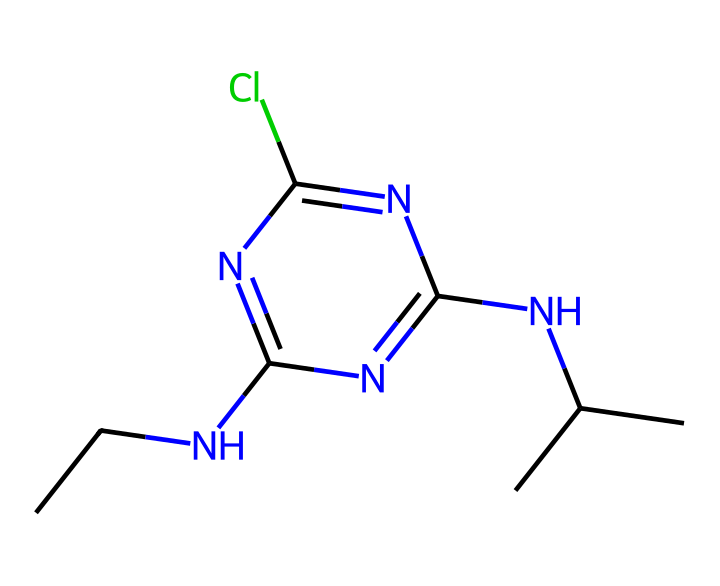What is the molecular formula for atrazine? To determine the molecular formula from the SMILES representation, count the number of each atom present. The SMILES shows 10 carbon (C) atoms, 14 hydrogen (H) atoms, 3 nitrogen (N) atoms, and 1 chlorine (Cl) atom. Therefore, the molecular formula is C8H14ClN5.
Answer: C8H14ClN5 How many nitrogen atoms are present in the atrazine molecule? By examining the SMILES structure, we can identify that there are a total of 5 nitrogen (N) atoms in the representation. Each nitrogen is counted as it appears in the structure.
Answer: 5 Which functional group is likely responsible for atrazine's herbicidal activity? From the structure, the presence of the nitrogen atoms indicates an amine functional group. These groups are often associated with biological activity, including herbicides. Thus, the amine group is likely responsible for its activity.
Answer: amine Is atrazine a single or multi-ring structure? The SMILES shows a cyclic structure (indicated by the 'c' in 'c1nc' which denotes aromatic rings), confirming that atrazine has a multi-ring configuration due to the fused nitrogen-containing rings.
Answer: multi-ring What is the significance of chlorine in atrazine's structure? Chlorine (Cl) in atrazine serves to enhance its herbicidal properties by increasing its lipophilicity, which helps it penetrate plant tissues effectively. Hence, the chlorine plays a pivotal role in its herbicidal effectiveness.
Answer: enhances herbicidal properties Does atrazine contain carbon branching in its structure? Analyzing the SMILES depiction reveals that there are branches present, particularly indicated by the isopropyl group (C(C)C). Therefore, it is confirmed that there is carbon branching in the structure.
Answer: yes 